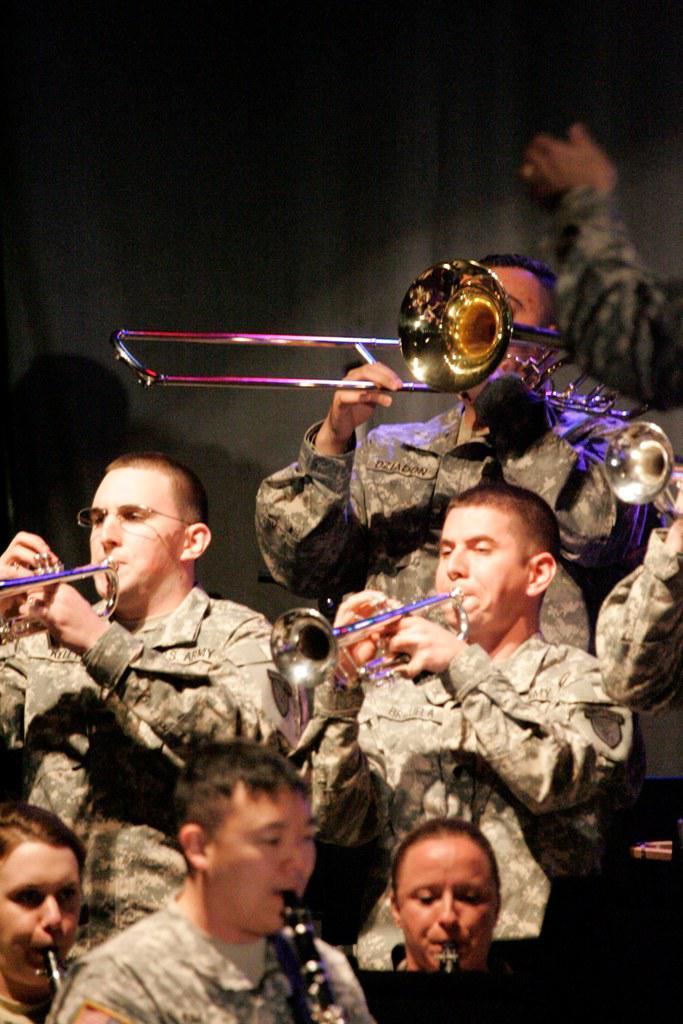Please provide a concise description of this image. In the image in the center we can see few peoples were standing and they were playing trumpet instrument. In the background there is a wall. 